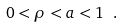<formula> <loc_0><loc_0><loc_500><loc_500>0 < \rho < a < 1 \ .</formula> 